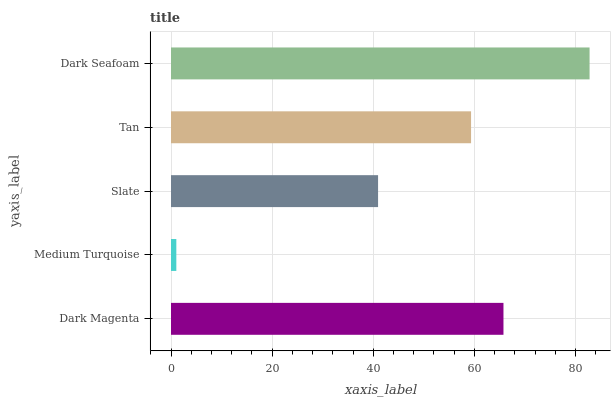Is Medium Turquoise the minimum?
Answer yes or no. Yes. Is Dark Seafoam the maximum?
Answer yes or no. Yes. Is Slate the minimum?
Answer yes or no. No. Is Slate the maximum?
Answer yes or no. No. Is Slate greater than Medium Turquoise?
Answer yes or no. Yes. Is Medium Turquoise less than Slate?
Answer yes or no. Yes. Is Medium Turquoise greater than Slate?
Answer yes or no. No. Is Slate less than Medium Turquoise?
Answer yes or no. No. Is Tan the high median?
Answer yes or no. Yes. Is Tan the low median?
Answer yes or no. Yes. Is Dark Magenta the high median?
Answer yes or no. No. Is Dark Magenta the low median?
Answer yes or no. No. 